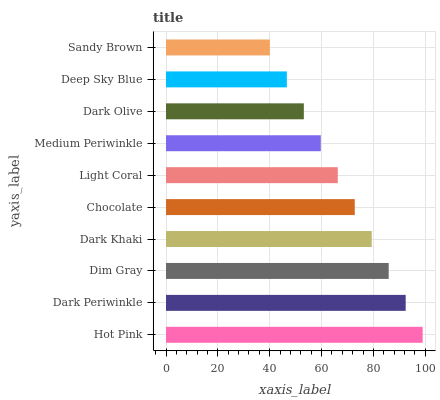Is Sandy Brown the minimum?
Answer yes or no. Yes. Is Hot Pink the maximum?
Answer yes or no. Yes. Is Dark Periwinkle the minimum?
Answer yes or no. No. Is Dark Periwinkle the maximum?
Answer yes or no. No. Is Hot Pink greater than Dark Periwinkle?
Answer yes or no. Yes. Is Dark Periwinkle less than Hot Pink?
Answer yes or no. Yes. Is Dark Periwinkle greater than Hot Pink?
Answer yes or no. No. Is Hot Pink less than Dark Periwinkle?
Answer yes or no. No. Is Chocolate the high median?
Answer yes or no. Yes. Is Light Coral the low median?
Answer yes or no. Yes. Is Medium Periwinkle the high median?
Answer yes or no. No. Is Chocolate the low median?
Answer yes or no. No. 